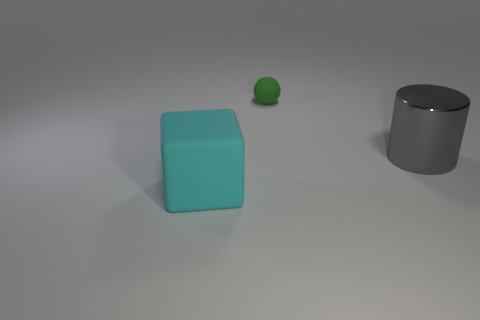Can you tell the lighting direction in this image? The lighting in the image seems to be coming from the upper left side, as indicated by the shadows cast towards the bottom right. This directional light creates soft shadows and highlights on the objects, giving a sense of depth to the scene. 